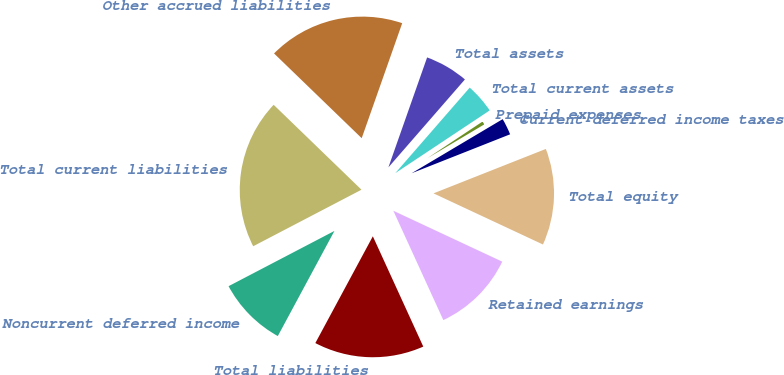Convert chart. <chart><loc_0><loc_0><loc_500><loc_500><pie_chart><fcel>Current deferred income taxes<fcel>Prepaid expenses<fcel>Total current assets<fcel>Total assets<fcel>Other accrued liabilities<fcel>Total current liabilities<fcel>Noncurrent deferred income<fcel>Total liabilities<fcel>Retained earnings<fcel>Total equity<nl><fcel>2.54%<fcel>0.8%<fcel>4.27%<fcel>6.01%<fcel>18.16%<fcel>19.89%<fcel>9.48%<fcel>14.69%<fcel>11.22%<fcel>12.95%<nl></chart> 